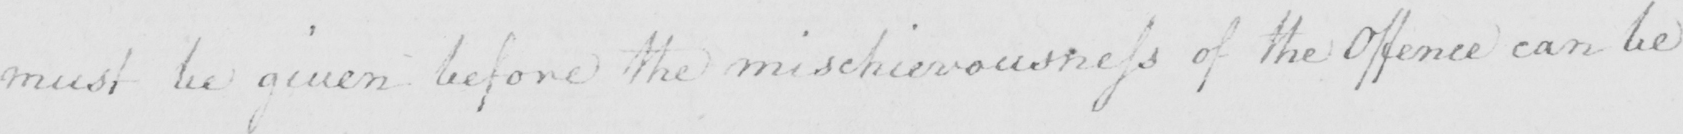What does this handwritten line say? must be given before the mischievousness of the Offence can be 